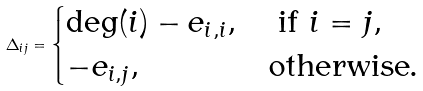Convert formula to latex. <formula><loc_0><loc_0><loc_500><loc_500>\Delta _ { i j } = \begin{cases} \deg ( i ) - e _ { i , i } , & \text { if } i = j , \\ - e _ { i , j } , & \text {otherwise} . \end{cases}</formula> 